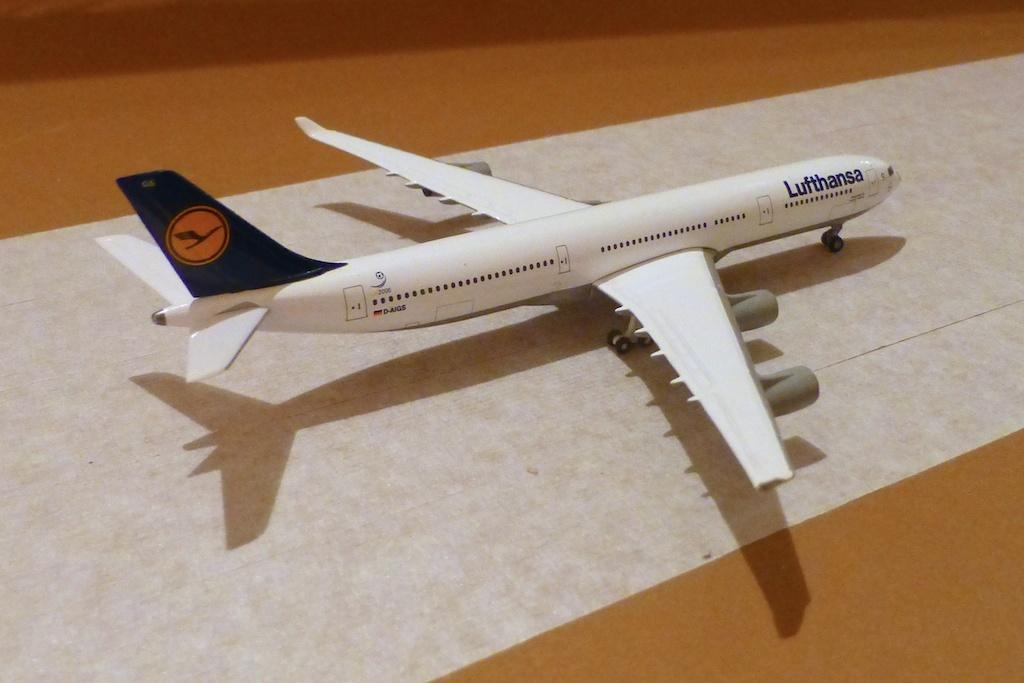What is the main object in the image? There is an aeroplane toy in the image. Where is the aeroplane toy located? The aeroplane toy is on a table. What type of jam is spread on the animal in the image? There is no jam or animal present in the image; it only features an aeroplane toy on a table. 